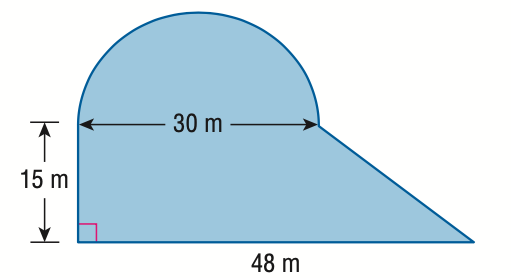Answer the mathemtical geometry problem and directly provide the correct option letter.
Question: Find the area of the figure.
Choices: A: 938.4 B: 1291.9 C: 1523.4 D: 1876.9 A 